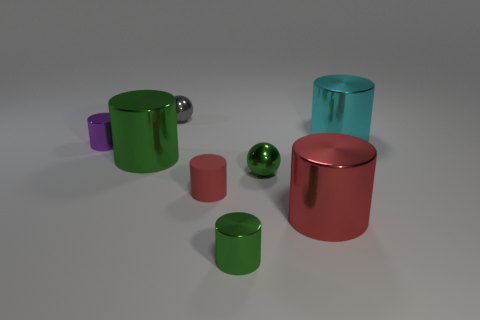The big thing that is the same color as the rubber cylinder is what shape?
Your response must be concise. Cylinder. The object that is both behind the purple metal object and in front of the gray metal thing is made of what material?
Ensure brevity in your answer.  Metal. There is a big object that is behind the purple metallic cylinder; what is its shape?
Your response must be concise. Cylinder. The large shiny thing that is behind the metal cylinder that is to the left of the large green metallic cylinder is what shape?
Provide a succinct answer. Cylinder. Are there any tiny brown matte objects of the same shape as the gray shiny object?
Offer a terse response. No. There is a red shiny object that is the same size as the cyan metal object; what shape is it?
Your response must be concise. Cylinder. There is a metal ball that is behind the tiny metallic ball that is on the right side of the tiny red rubber object; are there any metallic cylinders that are to the left of it?
Ensure brevity in your answer.  Yes. Is there a red shiny object of the same size as the rubber object?
Give a very brief answer. No. What size is the green shiny cylinder right of the tiny gray ball?
Make the answer very short. Small. There is a metal sphere that is behind the small metallic sphere that is in front of the small cylinder that is to the left of the big green cylinder; what color is it?
Offer a very short reply. Gray. 